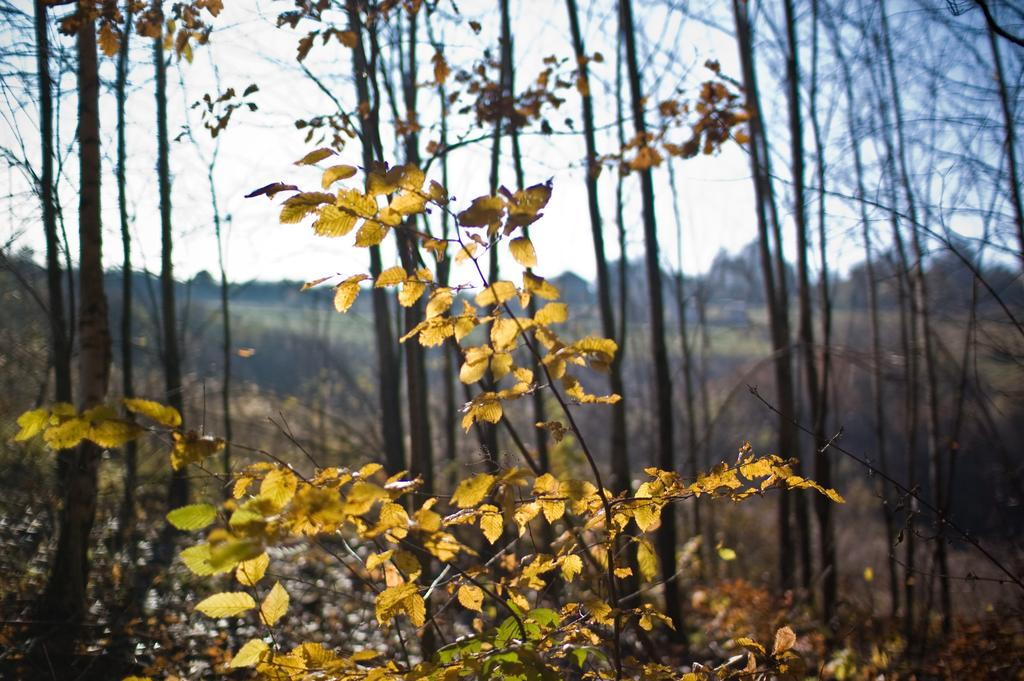What type of vegetation can be seen in the image? There is a plant and trees in the image. What part of the plant is visible in the image? Leaves are present in the image. How would you describe the background of the image? The background of the image is blurry. What can be seen in the far distance of the image? The sky is visible in the background of the image. What time does the clock show in the image? There is no clock present in the image. What type of scarf is wrapped around the tree in the image? There is no scarf present in the image; it only features a plant and trees. 